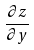<formula> <loc_0><loc_0><loc_500><loc_500>\frac { \partial z } { \partial y }</formula> 